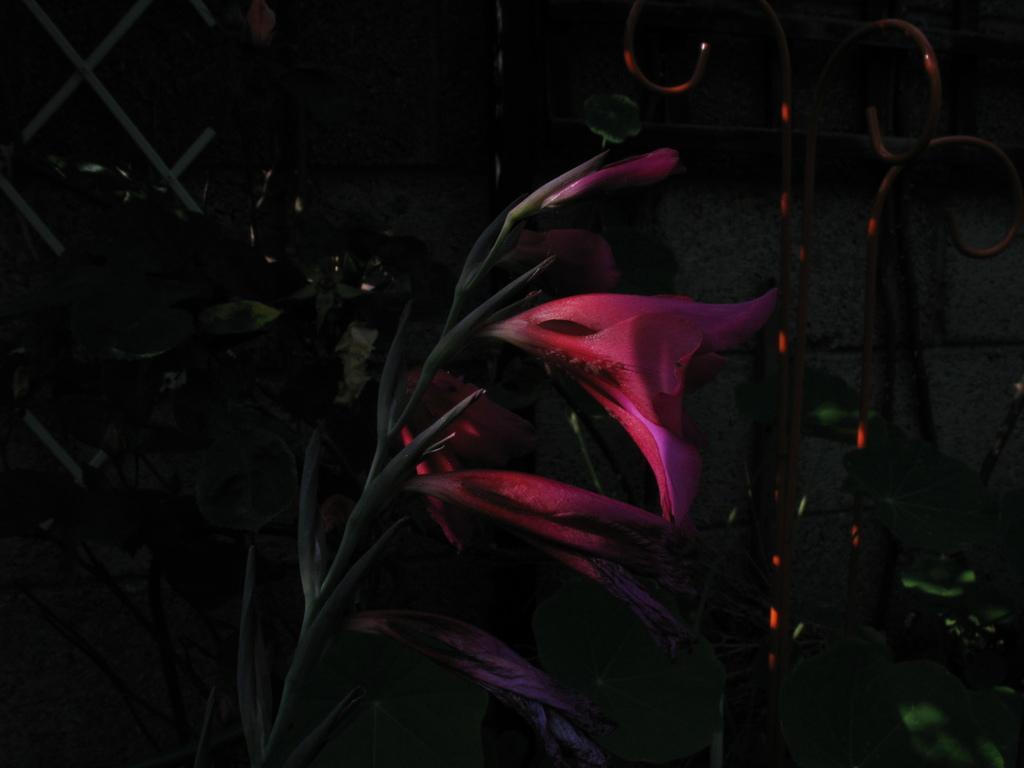Describe this image in one or two sentences. In this image I can see few flowers in pink color and few green color leaves. I can see the wall and the iron railing. 